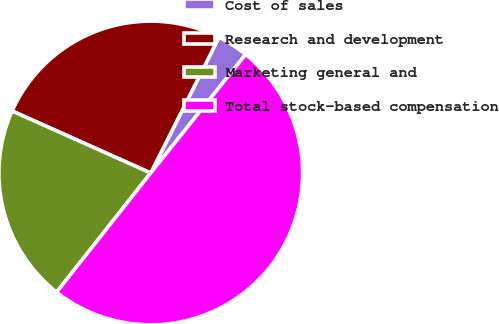Convert chart to OTSL. <chart><loc_0><loc_0><loc_500><loc_500><pie_chart><fcel>Cost of sales<fcel>Research and development<fcel>Marketing general and<fcel>Total stock-based compensation<nl><fcel>3.33%<fcel>25.72%<fcel>21.06%<fcel>49.89%<nl></chart> 